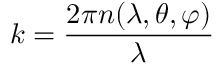Convert formula to latex. <formula><loc_0><loc_0><loc_500><loc_500>k = \frac { 2 \pi n ( \lambda , \theta , \varphi ) } { \lambda }</formula> 